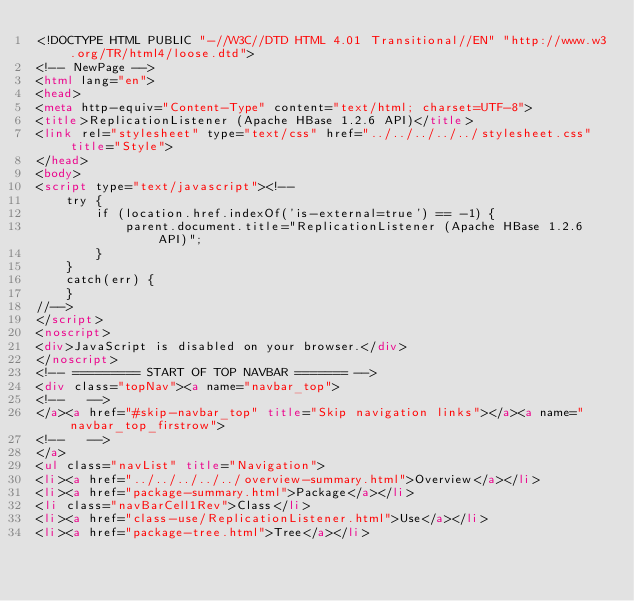<code> <loc_0><loc_0><loc_500><loc_500><_HTML_><!DOCTYPE HTML PUBLIC "-//W3C//DTD HTML 4.01 Transitional//EN" "http://www.w3.org/TR/html4/loose.dtd">
<!-- NewPage -->
<html lang="en">
<head>
<meta http-equiv="Content-Type" content="text/html; charset=UTF-8">
<title>ReplicationListener (Apache HBase 1.2.6 API)</title>
<link rel="stylesheet" type="text/css" href="../../../../../stylesheet.css" title="Style">
</head>
<body>
<script type="text/javascript"><!--
    try {
        if (location.href.indexOf('is-external=true') == -1) {
            parent.document.title="ReplicationListener (Apache HBase 1.2.6 API)";
        }
    }
    catch(err) {
    }
//-->
</script>
<noscript>
<div>JavaScript is disabled on your browser.</div>
</noscript>
<!-- ========= START OF TOP NAVBAR ======= -->
<div class="topNav"><a name="navbar_top">
<!--   -->
</a><a href="#skip-navbar_top" title="Skip navigation links"></a><a name="navbar_top_firstrow">
<!--   -->
</a>
<ul class="navList" title="Navigation">
<li><a href="../../../../../overview-summary.html">Overview</a></li>
<li><a href="package-summary.html">Package</a></li>
<li class="navBarCell1Rev">Class</li>
<li><a href="class-use/ReplicationListener.html">Use</a></li>
<li><a href="package-tree.html">Tree</a></li></code> 